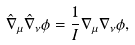Convert formula to latex. <formula><loc_0><loc_0><loc_500><loc_500>\hat { \nabla } _ { \mu } \hat { \nabla } _ { \nu } \phi = \frac { 1 } { I } \nabla _ { \mu } \nabla _ { \nu } \phi ,</formula> 